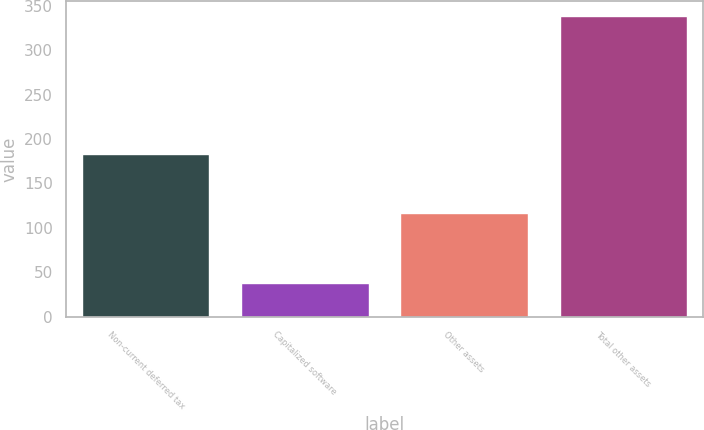Convert chart to OTSL. <chart><loc_0><loc_0><loc_500><loc_500><bar_chart><fcel>Non-current deferred tax<fcel>Capitalized software<fcel>Other assets<fcel>Total other assets<nl><fcel>183<fcel>38<fcel>117<fcel>338<nl></chart> 